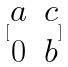Convert formula to latex. <formula><loc_0><loc_0><loc_500><loc_500>[ \begin{matrix} a & c \\ 0 & b \end{matrix} ]</formula> 